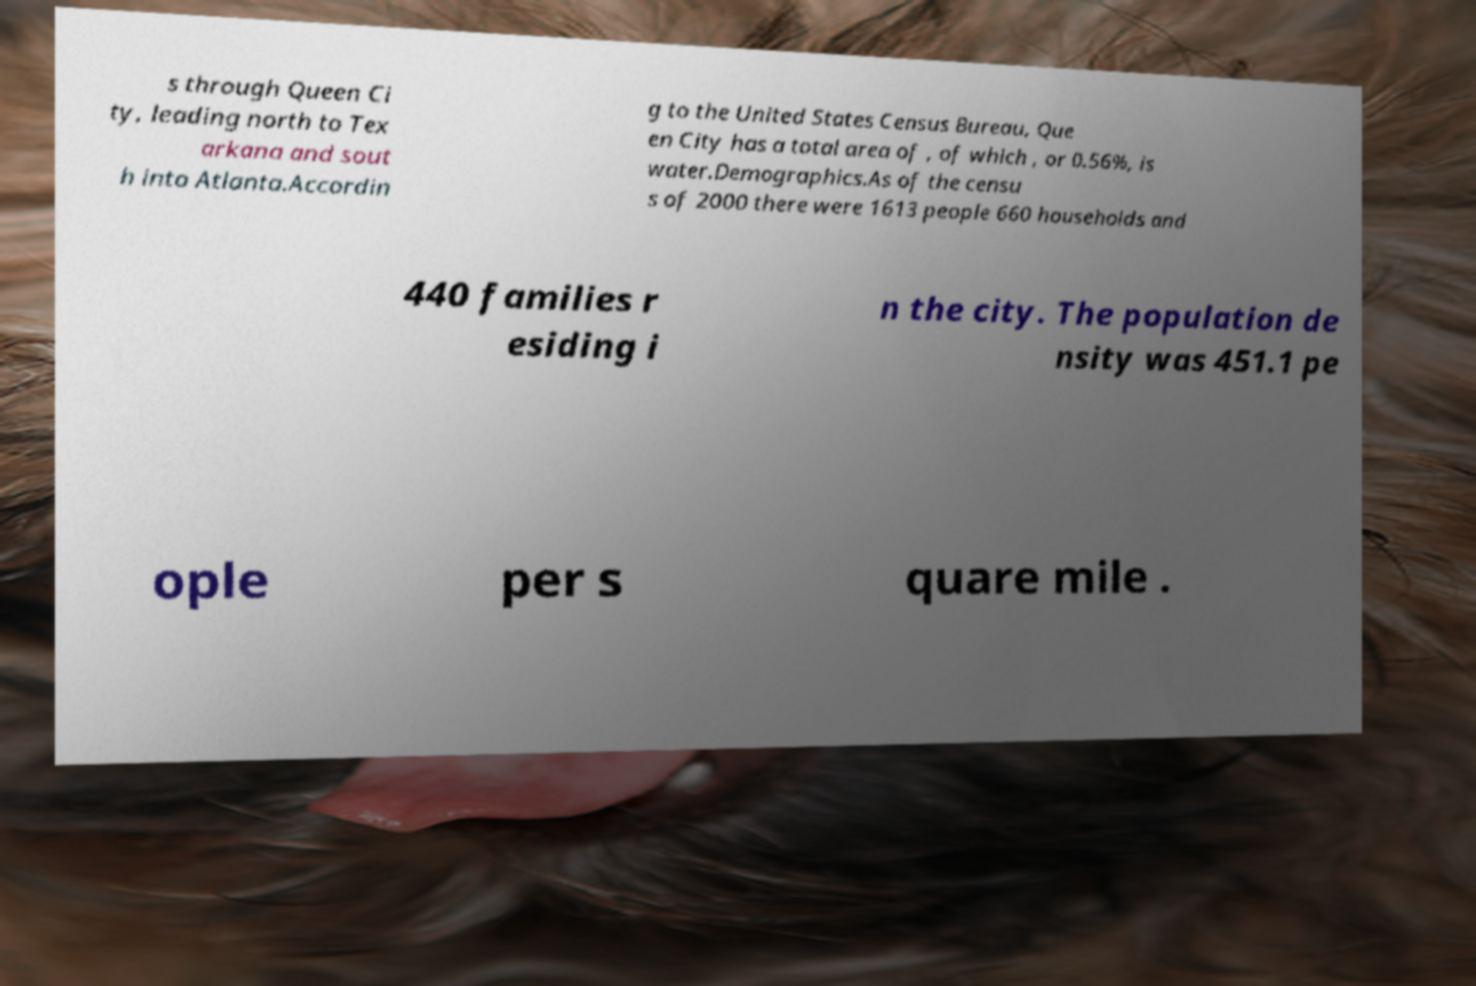Please identify and transcribe the text found in this image. s through Queen Ci ty, leading north to Tex arkana and sout h into Atlanta.Accordin g to the United States Census Bureau, Que en City has a total area of , of which , or 0.56%, is water.Demographics.As of the censu s of 2000 there were 1613 people 660 households and 440 families r esiding i n the city. The population de nsity was 451.1 pe ople per s quare mile . 